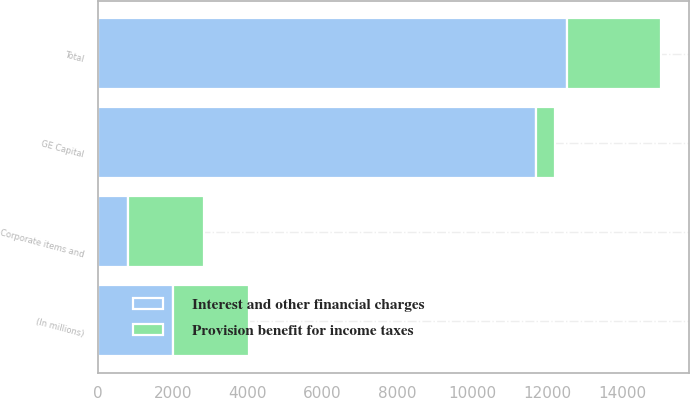Convert chart to OTSL. <chart><loc_0><loc_0><loc_500><loc_500><stacked_bar_chart><ecel><fcel>(In millions)<fcel>GE Capital<fcel>Corporate items and<fcel>Total<nl><fcel>Interest and other financial charges<fcel>2012<fcel>11697<fcel>811<fcel>12508<nl><fcel>Provision benefit for income taxes<fcel>2012<fcel>491<fcel>2013<fcel>2504<nl></chart> 